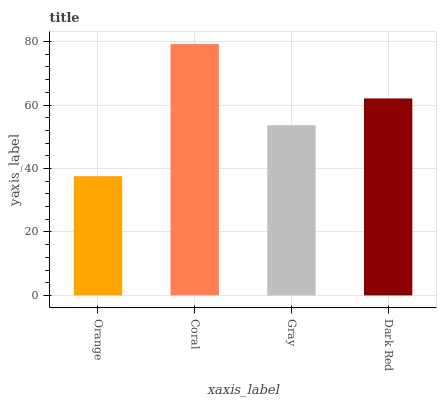Is Orange the minimum?
Answer yes or no. Yes. Is Coral the maximum?
Answer yes or no. Yes. Is Gray the minimum?
Answer yes or no. No. Is Gray the maximum?
Answer yes or no. No. Is Coral greater than Gray?
Answer yes or no. Yes. Is Gray less than Coral?
Answer yes or no. Yes. Is Gray greater than Coral?
Answer yes or no. No. Is Coral less than Gray?
Answer yes or no. No. Is Dark Red the high median?
Answer yes or no. Yes. Is Gray the low median?
Answer yes or no. Yes. Is Orange the high median?
Answer yes or no. No. Is Dark Red the low median?
Answer yes or no. No. 